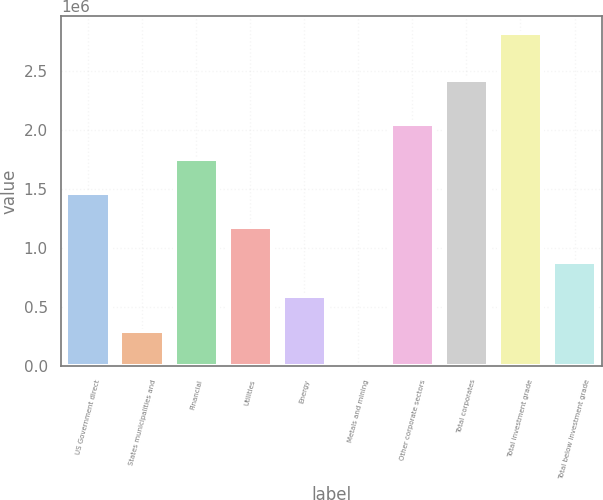Convert chart. <chart><loc_0><loc_0><loc_500><loc_500><bar_chart><fcel>US Government direct<fcel>States municipalities and<fcel>Financial<fcel>Utilities<fcel>Energy<fcel>Metals and mining<fcel>Other corporate sectors<fcel>Total corporates<fcel>Total investment grade<fcel>Total below investment grade<nl><fcel>1.46719e+06<fcel>298186<fcel>1.75944e+06<fcel>1.17494e+06<fcel>590437<fcel>5936<fcel>2.05169e+06<fcel>2.42367e+06<fcel>2.82876e+06<fcel>882688<nl></chart> 